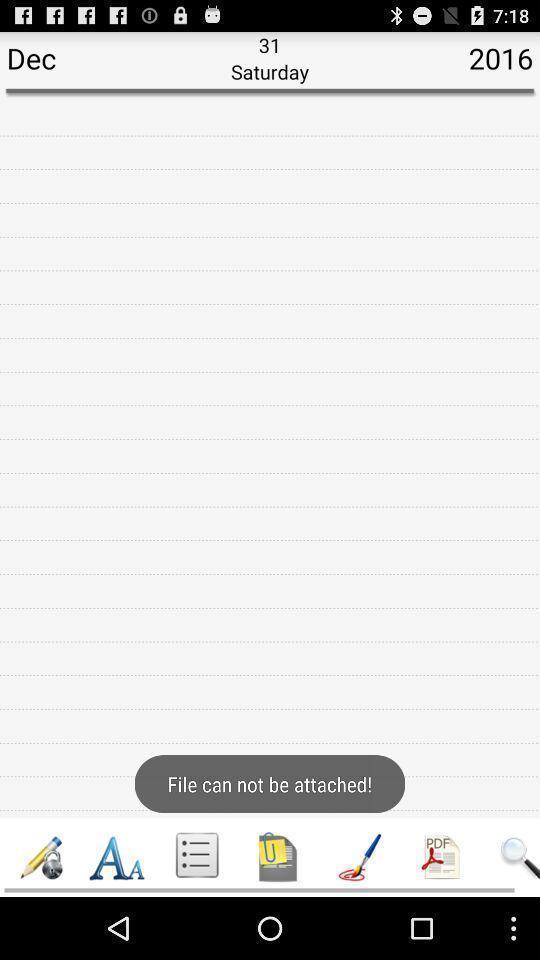What can you discern from this picture? Screen page to write a diary. 